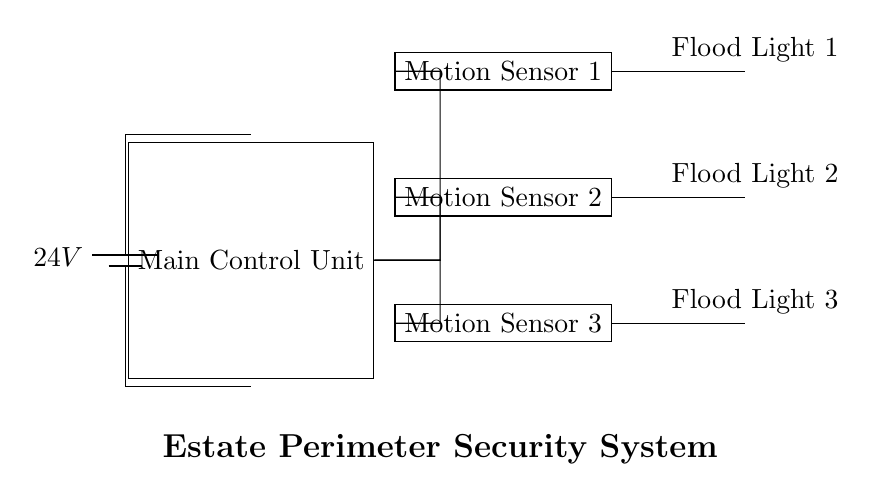What is the main voltage supply for the circuit? The main voltage supply is indicated as "24V," which is shown next to the battery symbol in the diagram. This directly indicates the voltage at which the circuit operates.
Answer: 24V What components are used for motion detection? The components labeled as "Motion Sensor 1," "Motion Sensor 2," and "Motion Sensor 3" are responsible for motion detection as indicated in the circuit diagram.
Answer: Motion Sensors How many flood lights are connected to the system? The circuit diagram shows three distinct flood lights labeled as "Flood Light 1," "Flood Light 2," and "Flood Light 3." Therefore, the total number of flood lights present is three.
Answer: Three What is the relationship between the motion sensors and the flood lights? Each motion sensor is connected to a corresponding flood light. The diagram shows that when motion is detected by any sensor, the respective flood light will turn on, indicating a direct functional connection.
Answer: Functional connection Which component acts as the control unit for the entire system? The component labeled as "Main Control Unit" is responsible for managing the operations of the motion sensors and flood lights, making it the central part of the system.
Answer: Main Control Unit What is the purpose of the movement sensors in this circuit? The movement sensors detect motion in the specified areas of the estate perimeter. Upon detection, they are designed to activate the flood lights, providing illumination and support for security purposes.
Answer: Security activation 